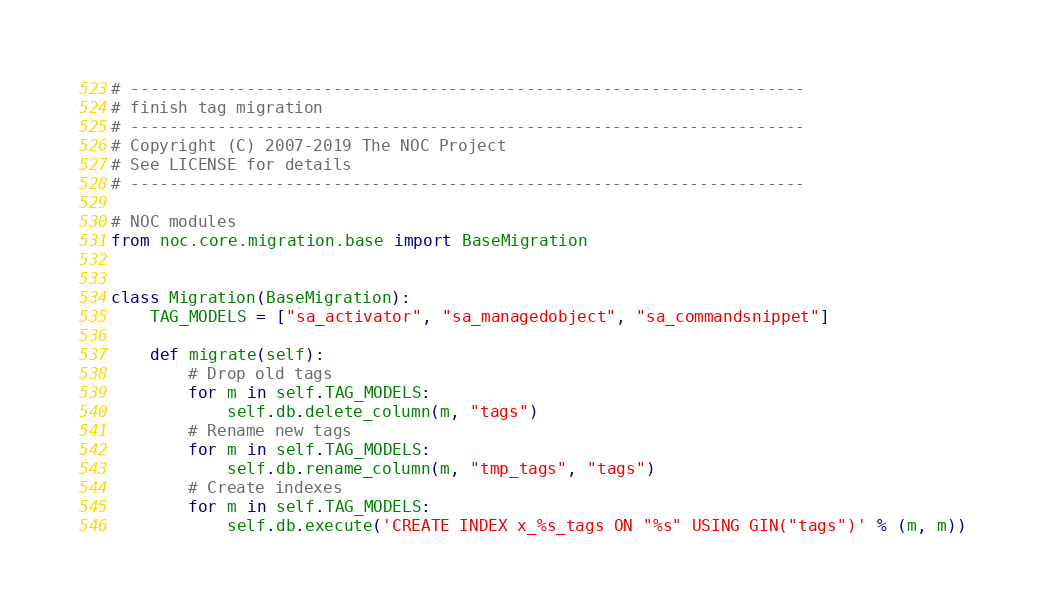<code> <loc_0><loc_0><loc_500><loc_500><_Python_># ----------------------------------------------------------------------
# finish tag migration
# ----------------------------------------------------------------------
# Copyright (C) 2007-2019 The NOC Project
# See LICENSE for details
# ----------------------------------------------------------------------

# NOC modules
from noc.core.migration.base import BaseMigration


class Migration(BaseMigration):
    TAG_MODELS = ["sa_activator", "sa_managedobject", "sa_commandsnippet"]

    def migrate(self):
        # Drop old tags
        for m in self.TAG_MODELS:
            self.db.delete_column(m, "tags")
        # Rename new tags
        for m in self.TAG_MODELS:
            self.db.rename_column(m, "tmp_tags", "tags")
        # Create indexes
        for m in self.TAG_MODELS:
            self.db.execute('CREATE INDEX x_%s_tags ON "%s" USING GIN("tags")' % (m, m))
</code> 